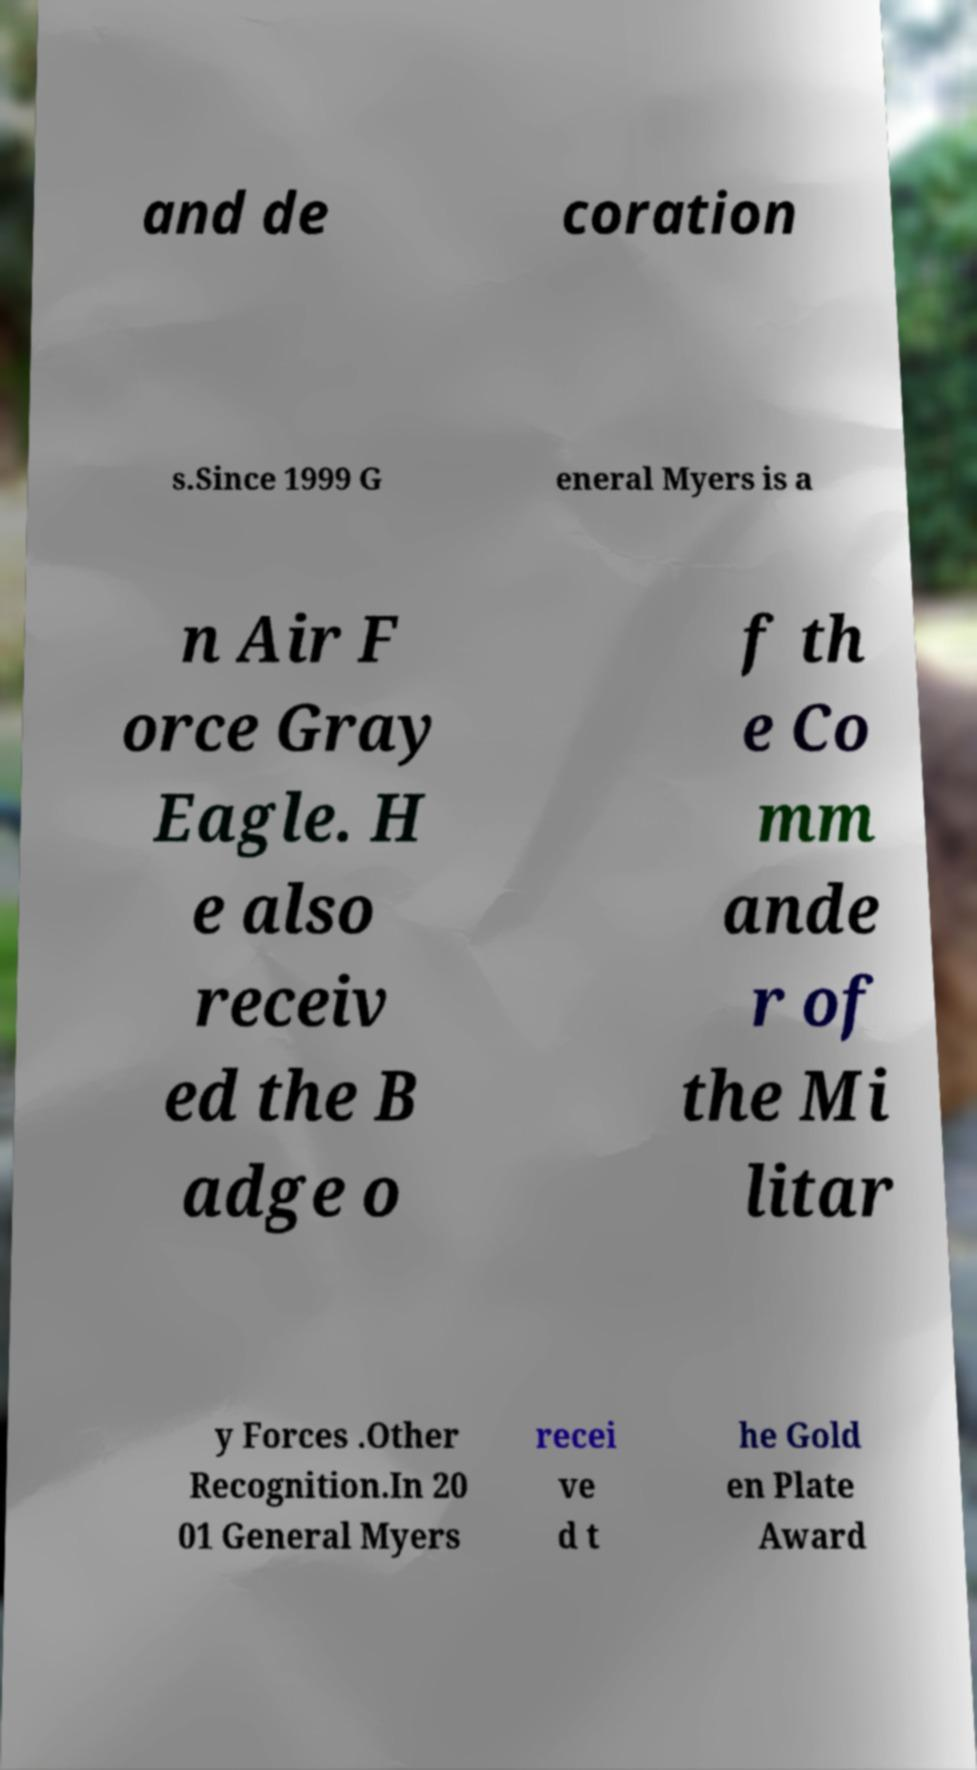Could you extract and type out the text from this image? and de coration s.Since 1999 G eneral Myers is a n Air F orce Gray Eagle. H e also receiv ed the B adge o f th e Co mm ande r of the Mi litar y Forces .Other Recognition.In 20 01 General Myers recei ve d t he Gold en Plate Award 